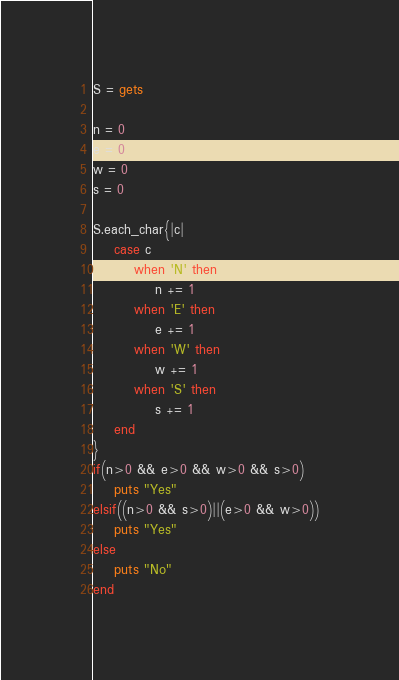<code> <loc_0><loc_0><loc_500><loc_500><_Ruby_>S = gets

n = 0
e = 0
w = 0
s = 0

S.each_char{|c|
	case c
		when 'N' then
			n += 1
		when 'E' then
			e += 1
		when 'W' then
			w += 1
		when 'S' then
			s += 1
	end
}
if(n>0 && e>0 && w>0 && s>0)
	puts "Yes"
elsif((n>0 && s>0)||(e>0 && w>0))
	puts "Yes"
else
	puts "No"
end</code> 